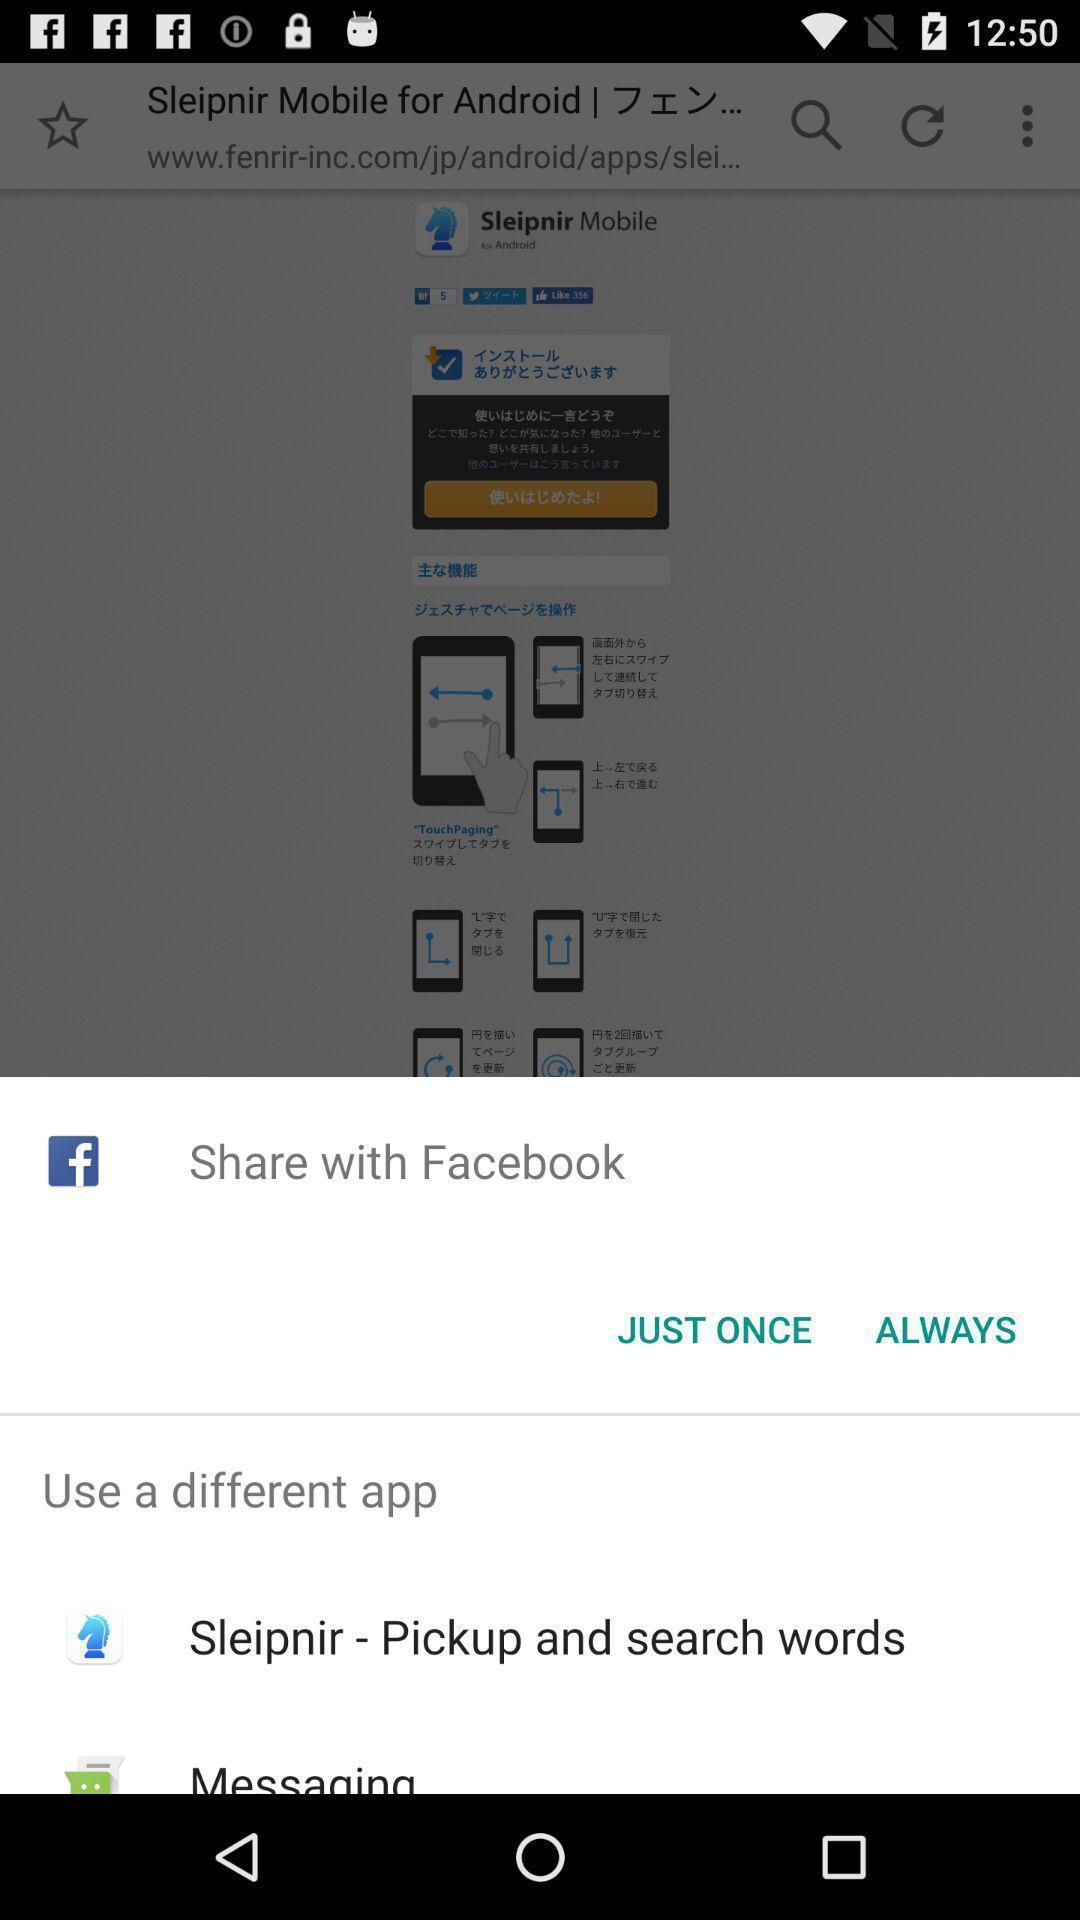Provide a detailed account of this screenshot. Popup of applications to share the information. 